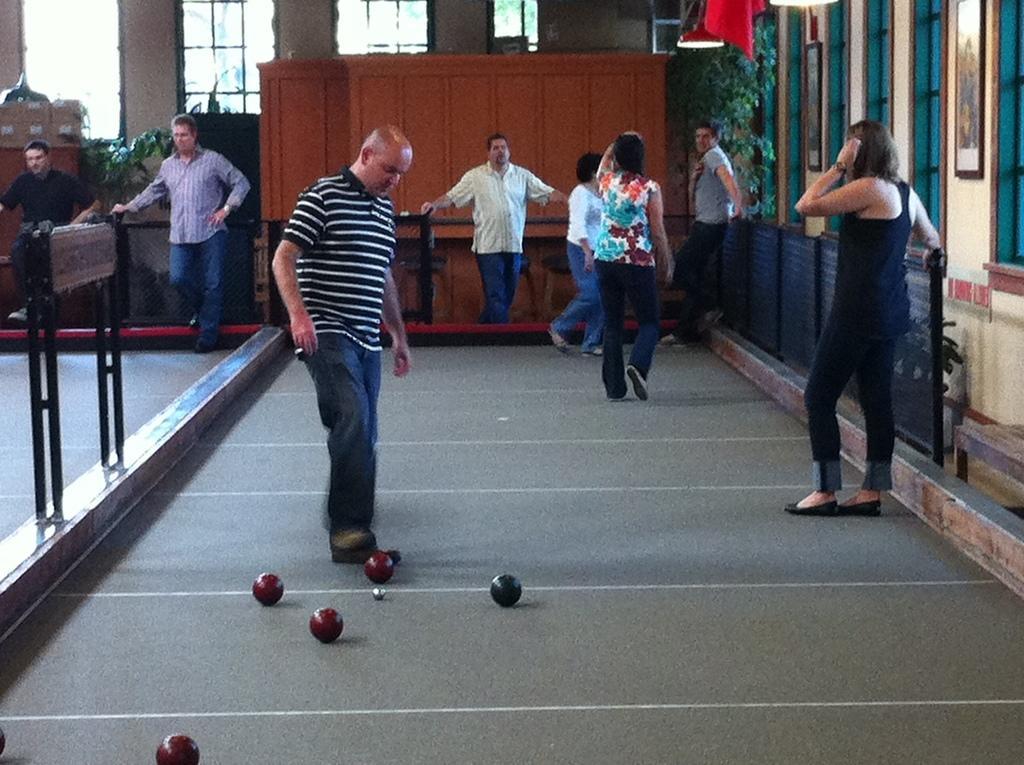Could you give a brief overview of what you see in this image? This is an inside view. At the bottom of the image I can see few balls on the ground. In the background there are few people standing. At the back of these people I can see a wall along with the windows. On the right side, I can see two frames are attached to the walls. 